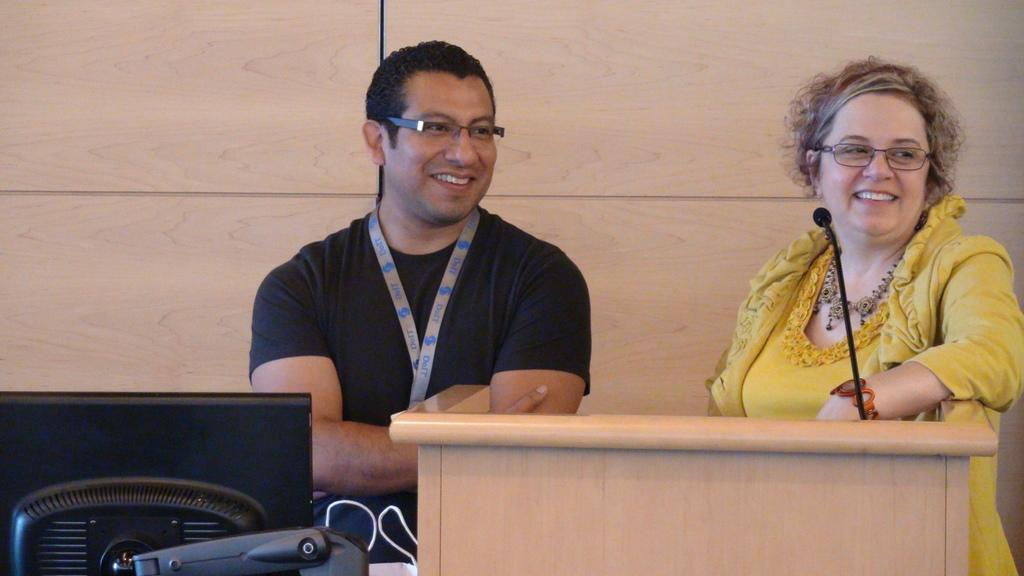How would you summarize this image in a sentence or two? In this picture we can see a man and a women. This is podium and there is a mike. Here we can see a monitor. On the background there is a wall. 